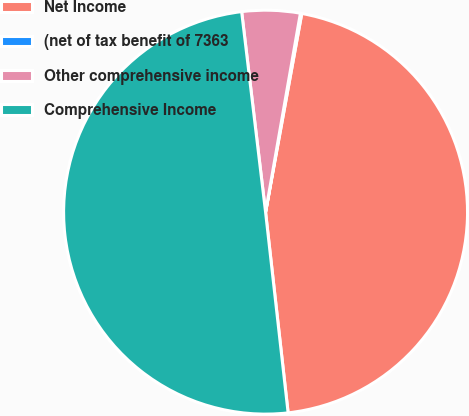Convert chart to OTSL. <chart><loc_0><loc_0><loc_500><loc_500><pie_chart><fcel>Net Income<fcel>(net of tax benefit of 7363<fcel>Other comprehensive income<fcel>Comprehensive Income<nl><fcel>45.35%<fcel>0.11%<fcel>4.65%<fcel>49.89%<nl></chart> 